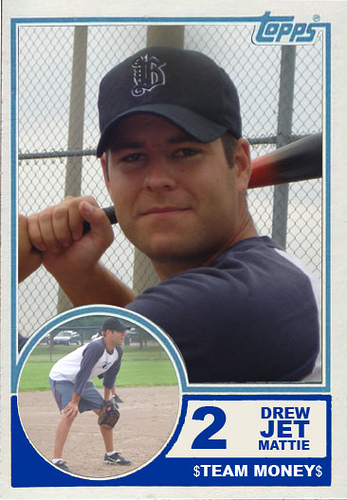Please extract the text content from this image. DREW JET MATTIE MONEY $TEAM 2 topps 